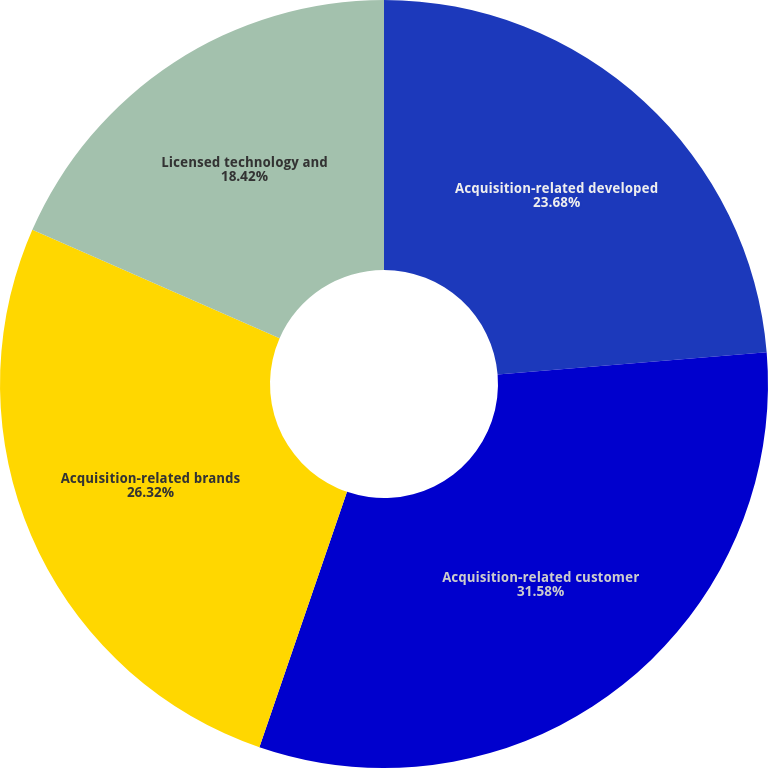Convert chart. <chart><loc_0><loc_0><loc_500><loc_500><pie_chart><fcel>Acquisition-related developed<fcel>Acquisition-related customer<fcel>Acquisition-related brands<fcel>Licensed technology and<nl><fcel>23.68%<fcel>31.58%<fcel>26.32%<fcel>18.42%<nl></chart> 